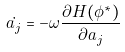Convert formula to latex. <formula><loc_0><loc_0><loc_500><loc_500>\dot { a _ { j } } = - \omega \frac { \partial H ( \phi ^ { * } ) } { \partial a _ { j } }</formula> 